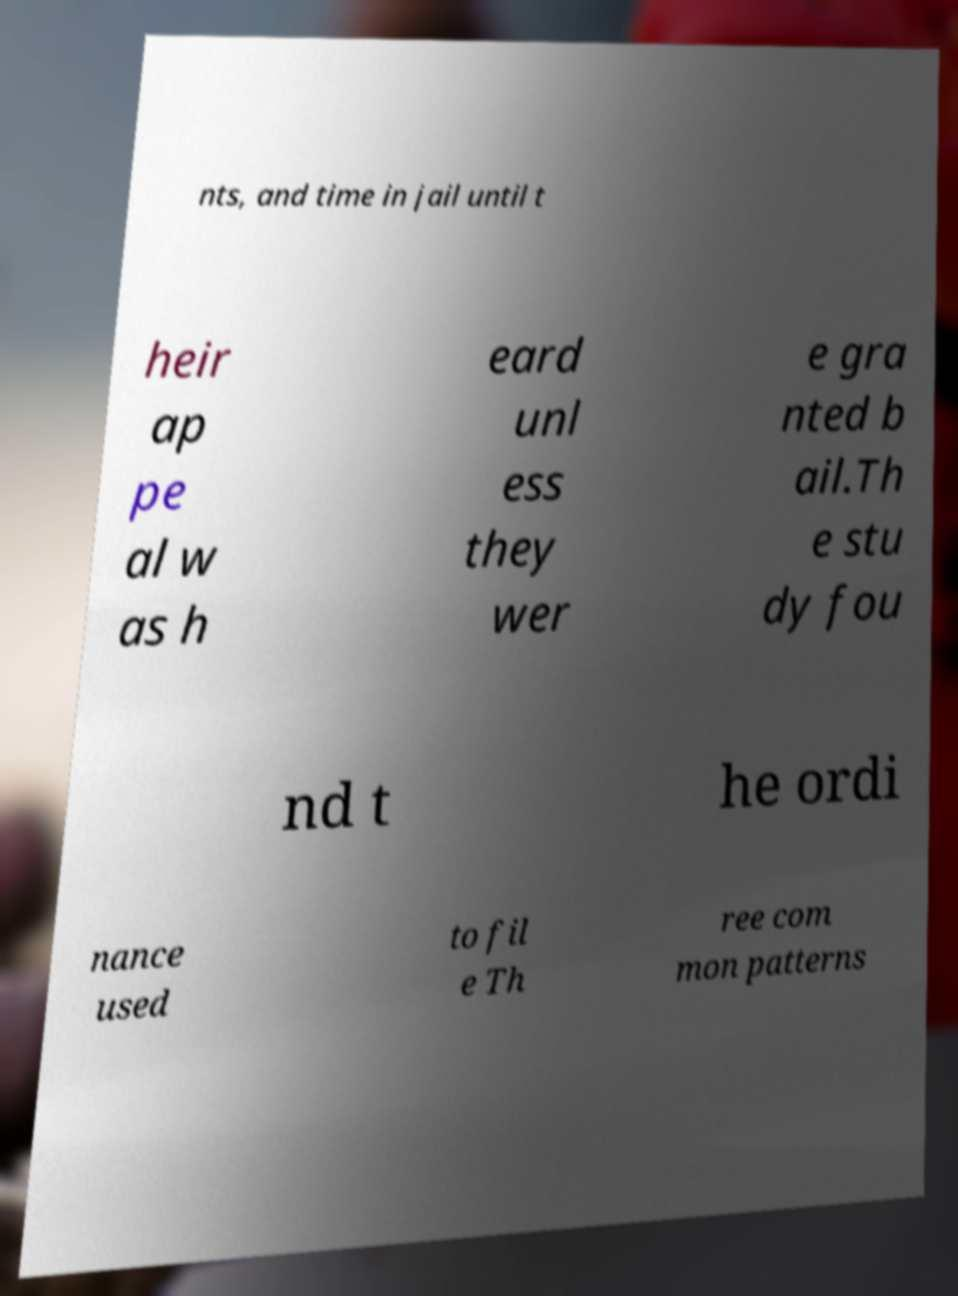For documentation purposes, I need the text within this image transcribed. Could you provide that? nts, and time in jail until t heir ap pe al w as h eard unl ess they wer e gra nted b ail.Th e stu dy fou nd t he ordi nance used to fil e Th ree com mon patterns 